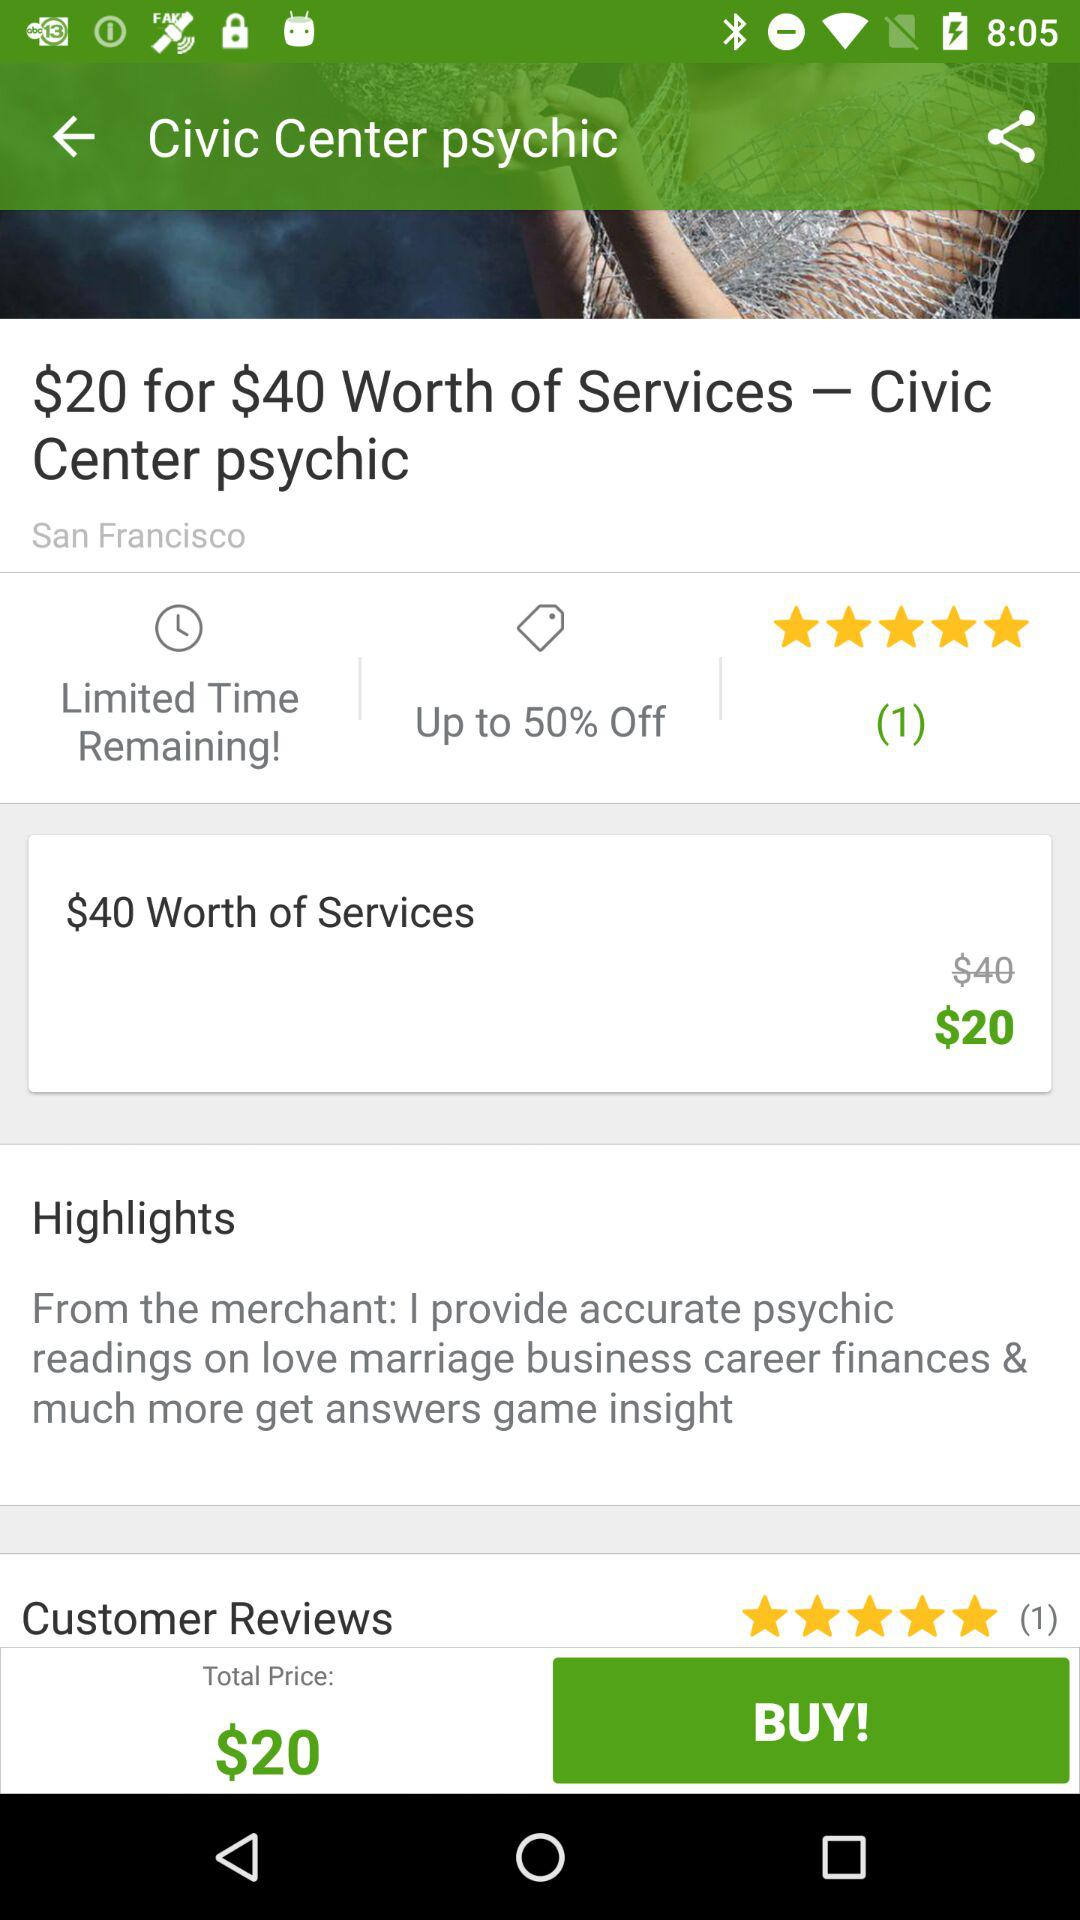What is the currency for the shown price? The currency for the shown price is dollars. 